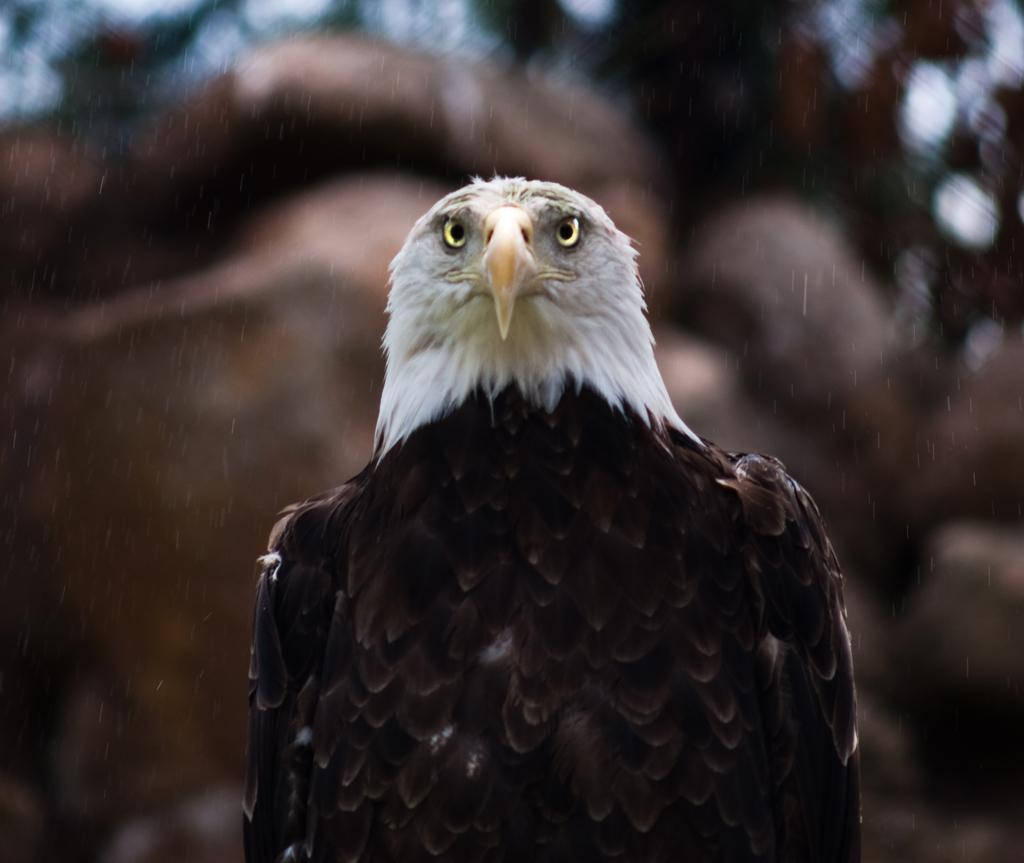Could you give a brief overview of what you see in this image? In this picture we can see an eagle and blurry background. 